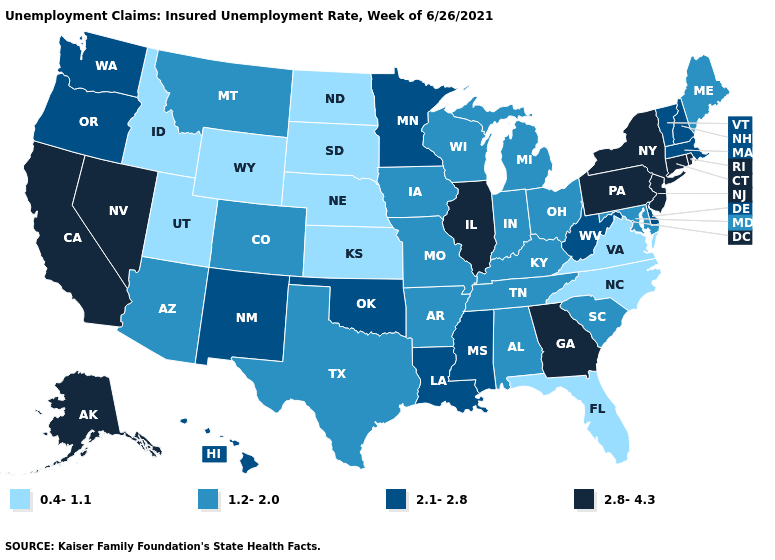Does the first symbol in the legend represent the smallest category?
Keep it brief. Yes. What is the value of West Virginia?
Concise answer only. 2.1-2.8. Which states hav the highest value in the Northeast?
Keep it brief. Connecticut, New Jersey, New York, Pennsylvania, Rhode Island. Which states have the lowest value in the USA?
Write a very short answer. Florida, Idaho, Kansas, Nebraska, North Carolina, North Dakota, South Dakota, Utah, Virginia, Wyoming. Name the states that have a value in the range 2.8-4.3?
Quick response, please. Alaska, California, Connecticut, Georgia, Illinois, Nevada, New Jersey, New York, Pennsylvania, Rhode Island. What is the lowest value in the USA?
Keep it brief. 0.4-1.1. Does Georgia have a higher value than Utah?
Give a very brief answer. Yes. Name the states that have a value in the range 1.2-2.0?
Be succinct. Alabama, Arizona, Arkansas, Colorado, Indiana, Iowa, Kentucky, Maine, Maryland, Michigan, Missouri, Montana, Ohio, South Carolina, Tennessee, Texas, Wisconsin. What is the value of Arkansas?
Be succinct. 1.2-2.0. Does Maine have the lowest value in the Northeast?
Answer briefly. Yes. Name the states that have a value in the range 0.4-1.1?
Be succinct. Florida, Idaho, Kansas, Nebraska, North Carolina, North Dakota, South Dakota, Utah, Virginia, Wyoming. Which states hav the highest value in the Northeast?
Give a very brief answer. Connecticut, New Jersey, New York, Pennsylvania, Rhode Island. Does Massachusetts have a higher value than North Carolina?
Short answer required. Yes. Which states have the lowest value in the USA?
Answer briefly. Florida, Idaho, Kansas, Nebraska, North Carolina, North Dakota, South Dakota, Utah, Virginia, Wyoming. Name the states that have a value in the range 1.2-2.0?
Give a very brief answer. Alabama, Arizona, Arkansas, Colorado, Indiana, Iowa, Kentucky, Maine, Maryland, Michigan, Missouri, Montana, Ohio, South Carolina, Tennessee, Texas, Wisconsin. 